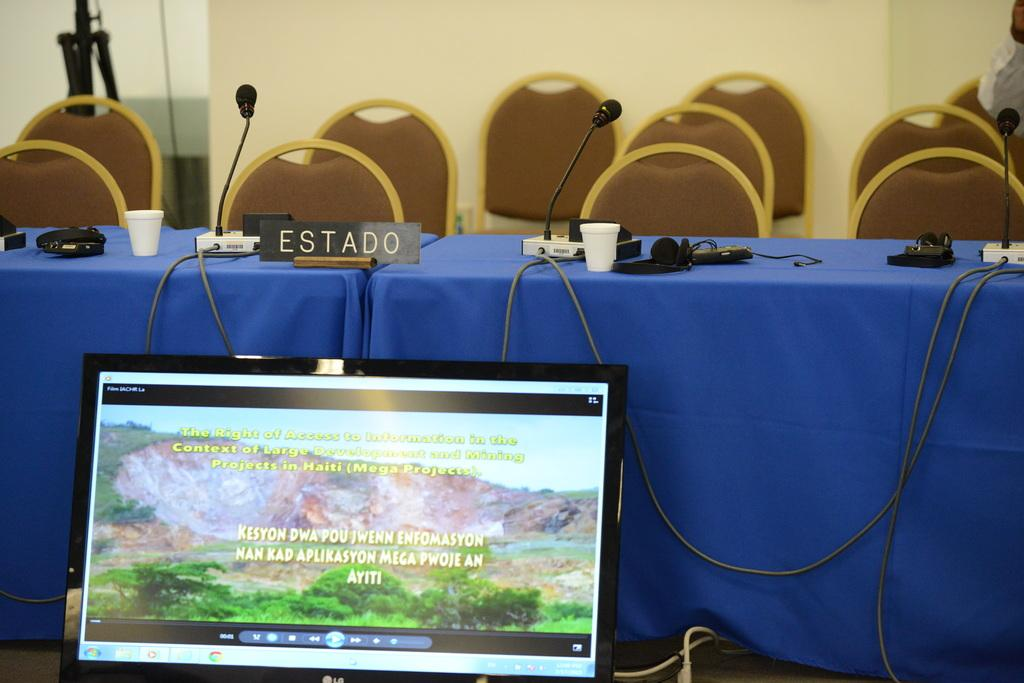<image>
Relay a brief, clear account of the picture shown. A Spanish language nameplate sits on a table covered with a blue tablecloth. 